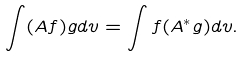<formula> <loc_0><loc_0><loc_500><loc_500>\int ( A f ) g d v = \int f ( A ^ { * } g ) d v .</formula> 